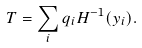Convert formula to latex. <formula><loc_0><loc_0><loc_500><loc_500>T = \sum _ { i } q _ { i } H ^ { - 1 } ( y _ { i } ) .</formula> 